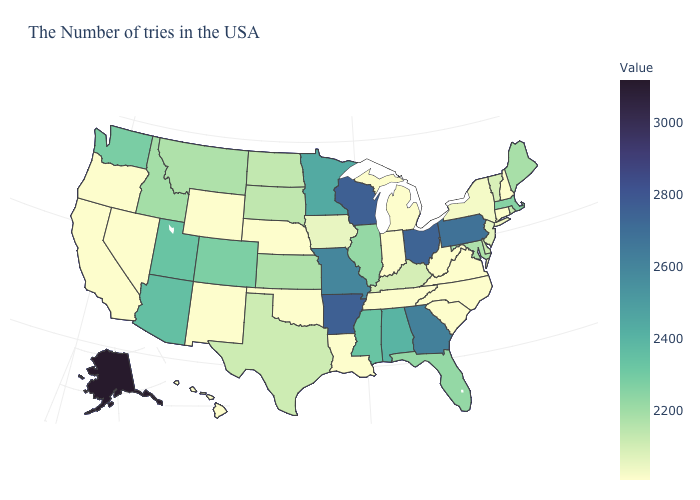Does New Mexico have the lowest value in the West?
Answer briefly. Yes. Does the map have missing data?
Short answer required. No. Which states have the lowest value in the Northeast?
Be succinct. New Hampshire, Connecticut. Among the states that border Missouri , which have the lowest value?
Concise answer only. Tennessee, Nebraska, Oklahoma. Does the map have missing data?
Keep it brief. No. 